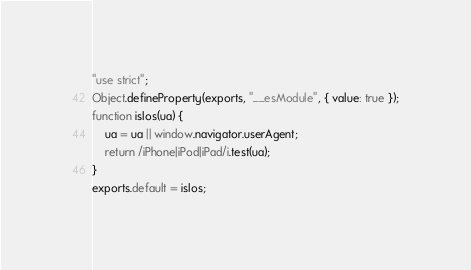<code> <loc_0><loc_0><loc_500><loc_500><_JavaScript_>"use strict";
Object.defineProperty(exports, "__esModule", { value: true });
function isIos(ua) {
    ua = ua || window.navigator.userAgent;
    return /iPhone|iPod|iPad/i.test(ua);
}
exports.default = isIos;
</code> 